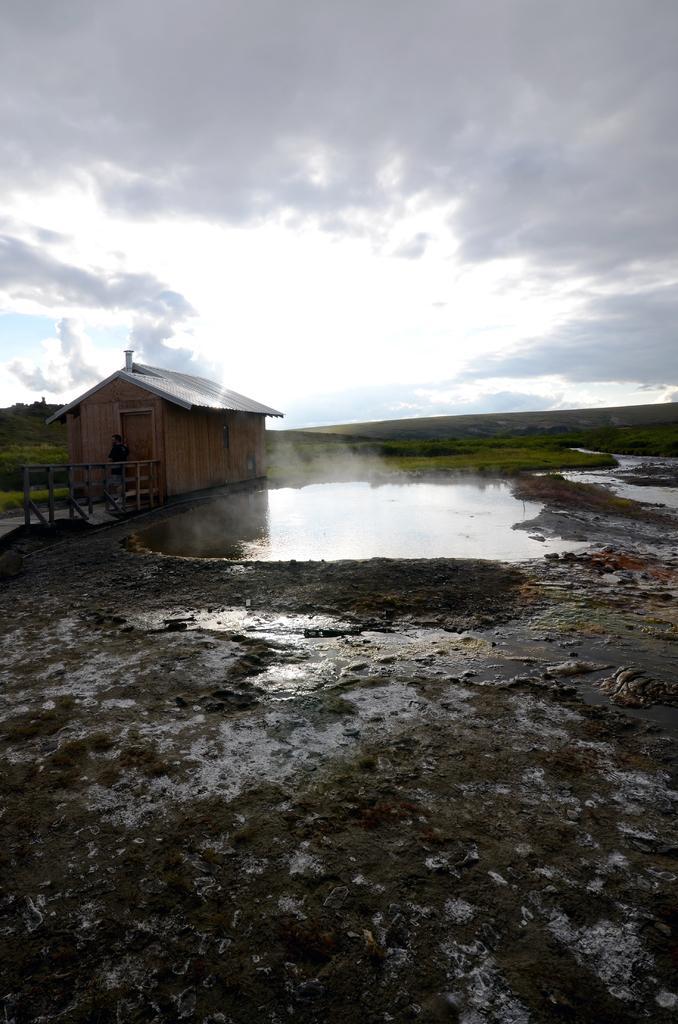Please provide a concise description of this image. In the foreground of this image, on the bottom, there is mud, land and water. Beside the water, there is a small house and the railing. In the background, there is greenery. On the top, there is sky and the cloud. 